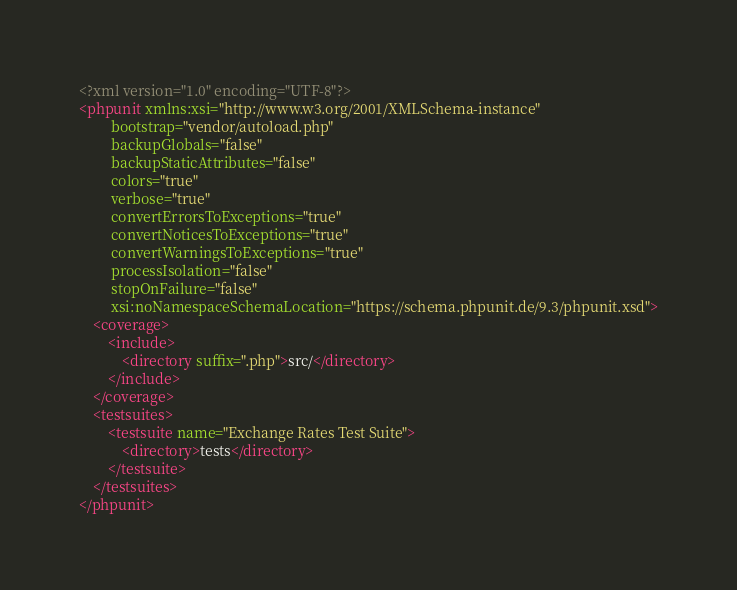<code> <loc_0><loc_0><loc_500><loc_500><_XML_><?xml version="1.0" encoding="UTF-8"?>
<phpunit xmlns:xsi="http://www.w3.org/2001/XMLSchema-instance"
         bootstrap="vendor/autoload.php"
         backupGlobals="false"
         backupStaticAttributes="false"
         colors="true"
         verbose="true"
         convertErrorsToExceptions="true"
         convertNoticesToExceptions="true"
         convertWarningsToExceptions="true"
         processIsolation="false"
         stopOnFailure="false"
         xsi:noNamespaceSchemaLocation="https://schema.phpunit.de/9.3/phpunit.xsd">
    <coverage>
        <include>
            <directory suffix=".php">src/</directory>
        </include>
    </coverage>
    <testsuites>
        <testsuite name="Exchange Rates Test Suite">
            <directory>tests</directory>
        </testsuite>
    </testsuites>
</phpunit>
</code> 